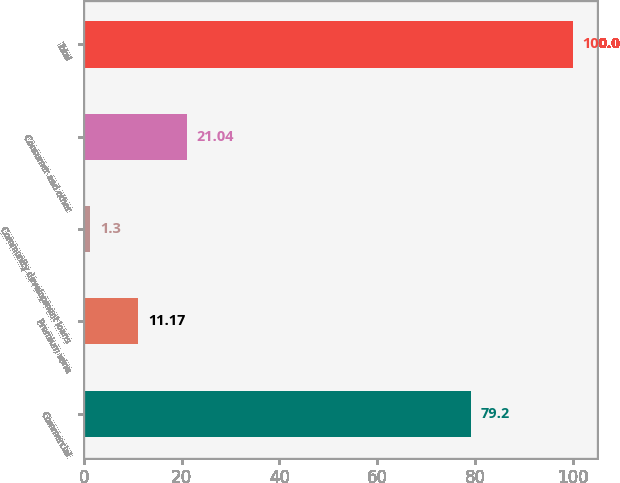Convert chart. <chart><loc_0><loc_0><loc_500><loc_500><bar_chart><fcel>Commercial<fcel>Premium wine<fcel>Community development loans<fcel>Consumer and other<fcel>Total<nl><fcel>79.2<fcel>11.17<fcel>1.3<fcel>21.04<fcel>100<nl></chart> 